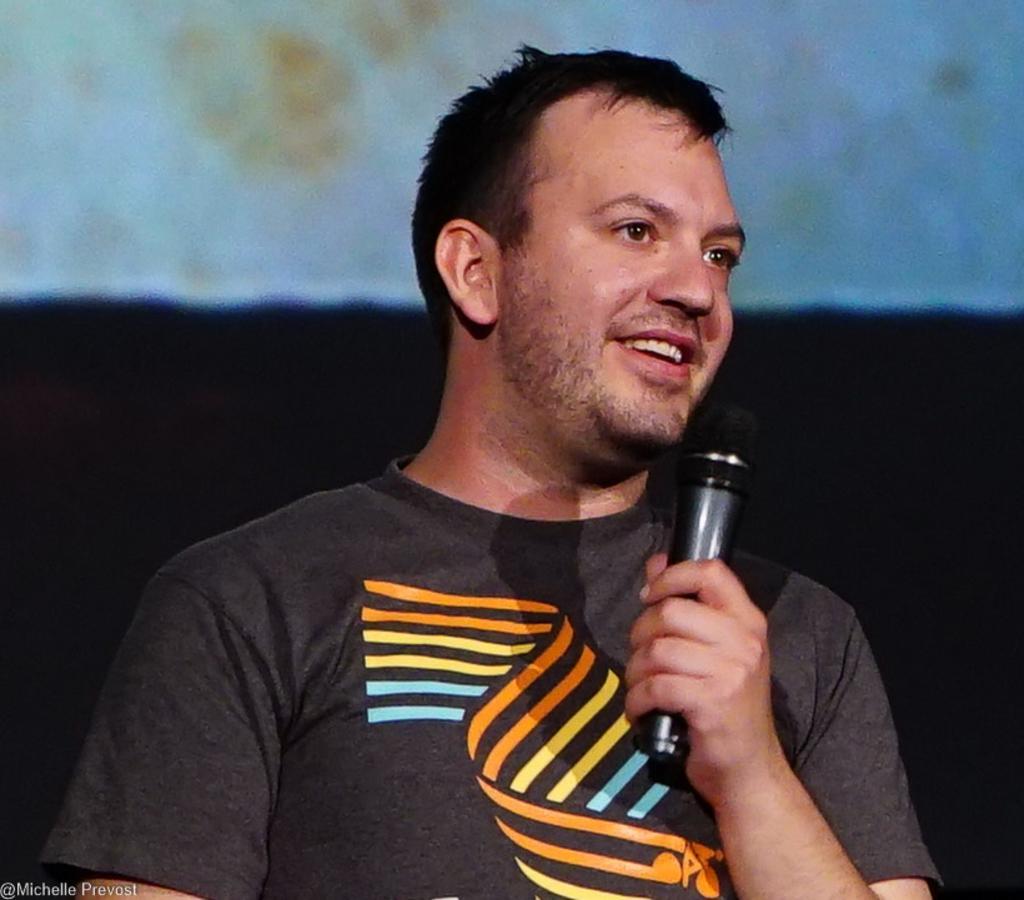Can you describe this image briefly? This is a picture of a person who is in black tee shirt and holding a mike. 